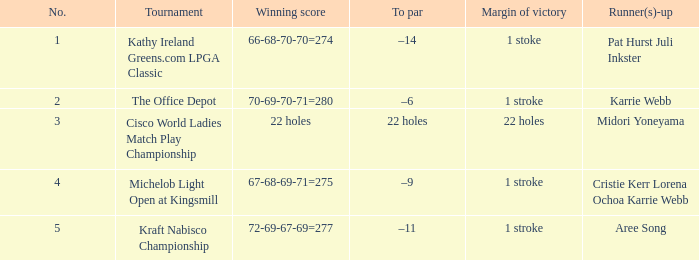Where is the victory margin located from mar 28, 2004? 1 stroke. 